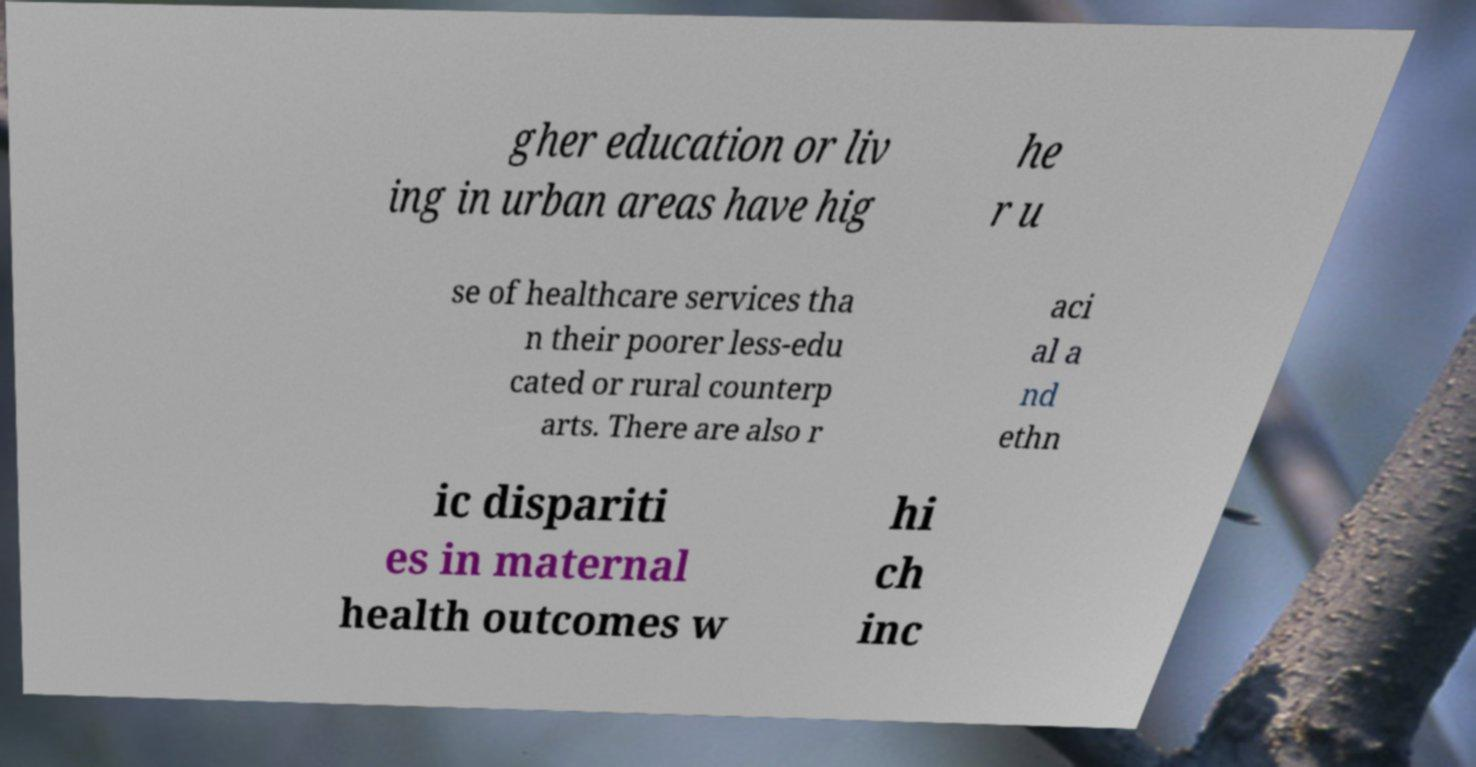Could you extract and type out the text from this image? gher education or liv ing in urban areas have hig he r u se of healthcare services tha n their poorer less-edu cated or rural counterp arts. There are also r aci al a nd ethn ic dispariti es in maternal health outcomes w hi ch inc 